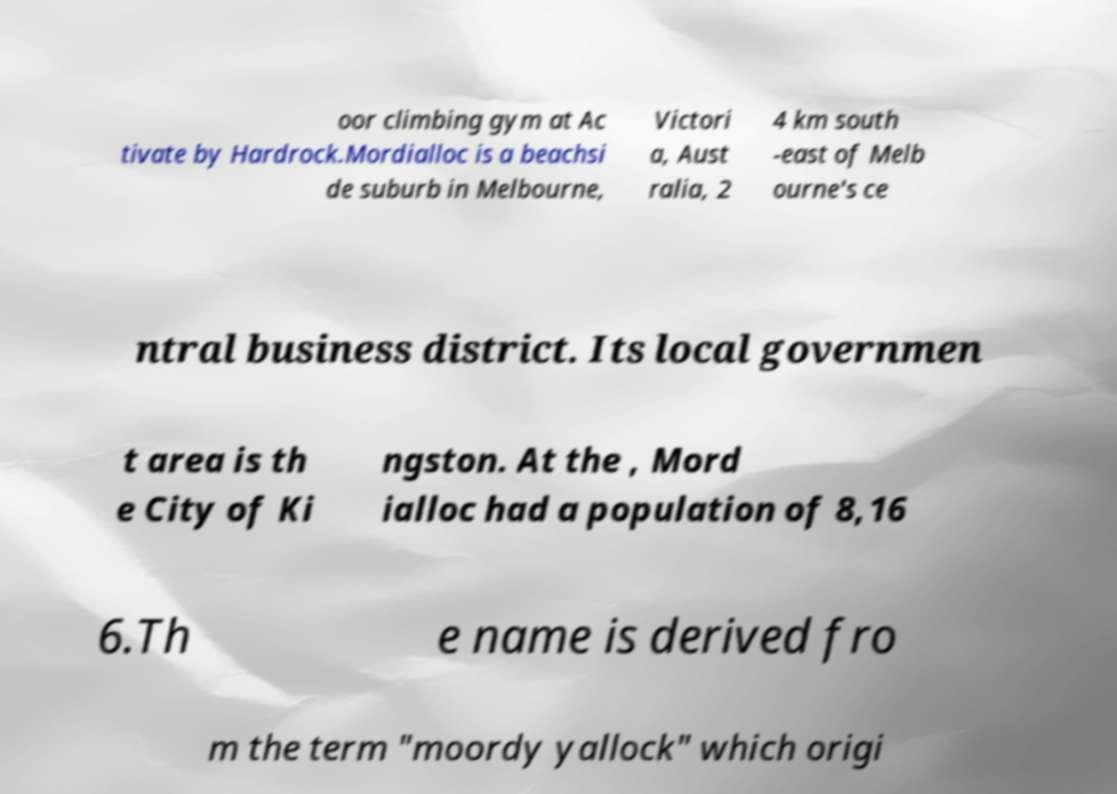For documentation purposes, I need the text within this image transcribed. Could you provide that? oor climbing gym at Ac tivate by Hardrock.Mordialloc is a beachsi de suburb in Melbourne, Victori a, Aust ralia, 2 4 km south -east of Melb ourne's ce ntral business district. Its local governmen t area is th e City of Ki ngston. At the , Mord ialloc had a population of 8,16 6.Th e name is derived fro m the term "moordy yallock" which origi 